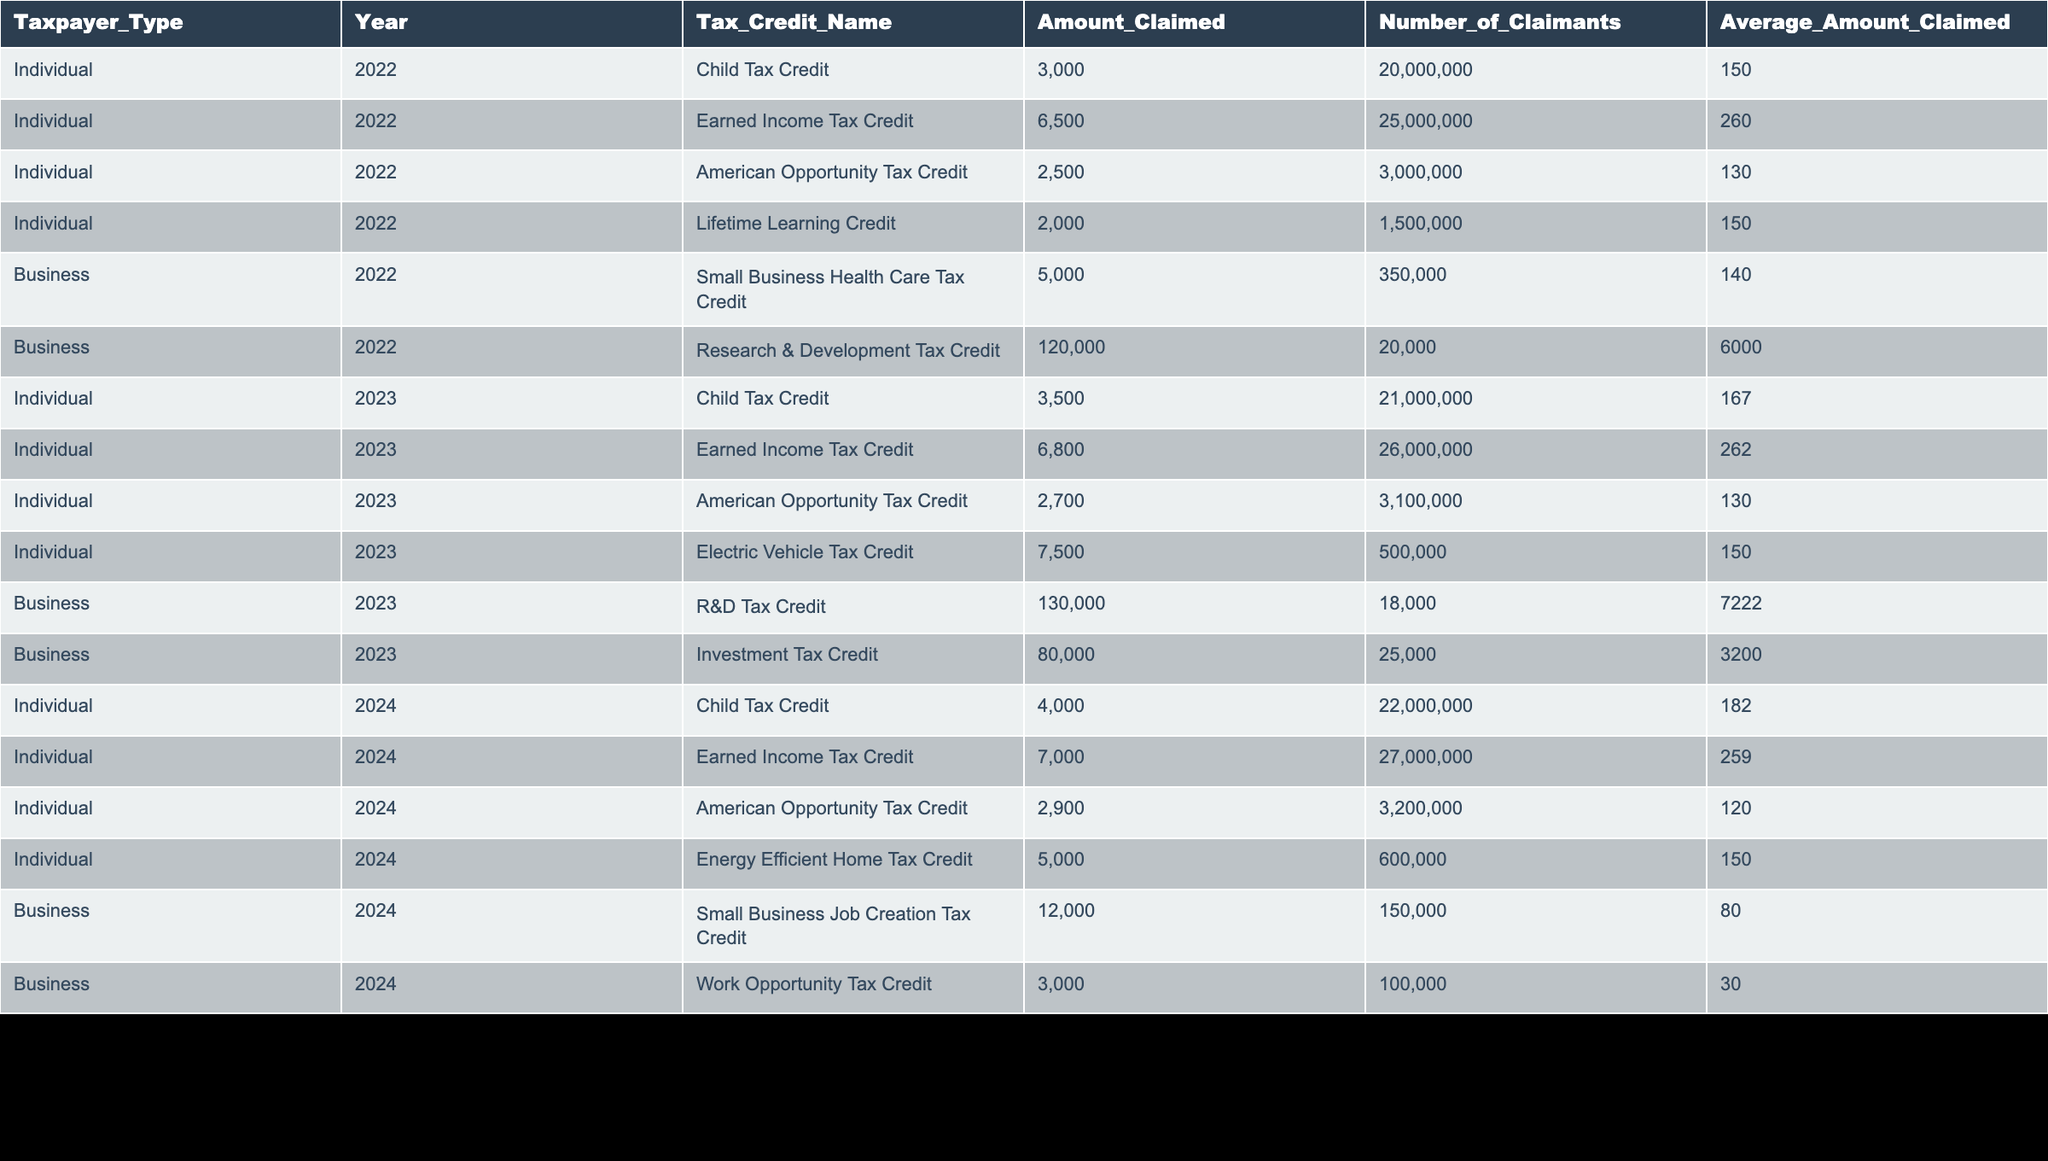What is the total amount claimed for the Earned Income Tax Credit in 2023? To find the total amount claimed for the Earned Income Tax Credit in 2023, I look for the corresponding row where the Year is 2023 and the Tax Credit Name is "Earned Income Tax Credit". The Amount Claimed in that row is 6800. Hence, the total amount claimed is 6800.
Answer: 6800 How many claimants were there for the American Opportunity Tax Credit in 2024? Referring to the row for the American Opportunity Tax Credit in 2024, I note that the Number of Claimants is listed as 3200000. Therefore, the number of claimants is 3200000.
Answer: 3200000 What is the average amount claimed for the Child Tax Credit by individuals in 2022? Looking at the row for the Child Tax Credit in 2022, the Average Amount Claimed is reported as 150. Therefore, the average amount claimed for the Child Tax Credit by individuals in that year is 150.
Answer: 150 Is the amount claimed for the Small Business Health Care Tax Credit greater than 5000? Checking the row for the Small Business Health Care Tax Credit in 2022, the Amount Claimed is reported as 5000. Since the amount claimed is equal to 5000 and not greater, the answer is no.
Answer: No Which tax credit had the highest average amount claimed in 2023? I will need to compare the Average Amount Claimed for each tax credit in 2023. The Average Amount Claimed for the Child Tax Credit is 167, for the Earned Income Tax Credit is 262, for the American Opportunity Tax Credit is 130, and for the Electric Vehicle Tax Credit is 150. The highest average is 262 from the Earned Income Tax Credit.
Answer: Earned Income Tax Credit What is the difference in the number of claimants for the Earned Income Tax Credit between 2022 and 2024? First, I find the Number of Claimants for the Earned Income Tax Credit in 2022, which is 25000000, and for 2024, it is 27000000. The difference is calculated as 27000000 - 25000000 = 2000000.
Answer: 2000000 How many claimants were there for the Electric Vehicle Tax Credit in 2023? Referring to the row for the Electric Vehicle Tax Credit in 2023, I see that the Number of Claimants is 500000. Thus, the number of claimants for this tax credit is 500000.
Answer: 500000 Was the amount claimed for the Research & Development Tax Credit in 2023 higher than that in 2022? Checking the rows for the Research & Development Tax Credit for both years, I note that in 2022 the amount claimed was 120000, while in 2023 it was 130000. Since 130000 is greater than 120000, the answer is yes.
Answer: Yes 